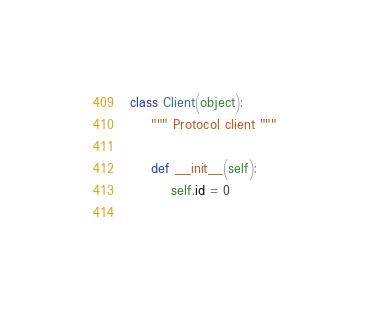Convert code to text. <code><loc_0><loc_0><loc_500><loc_500><_Python_>class Client(object):
    """ Protocol client """
    
    def __init__(self):
        self.id = 0
    </code> 